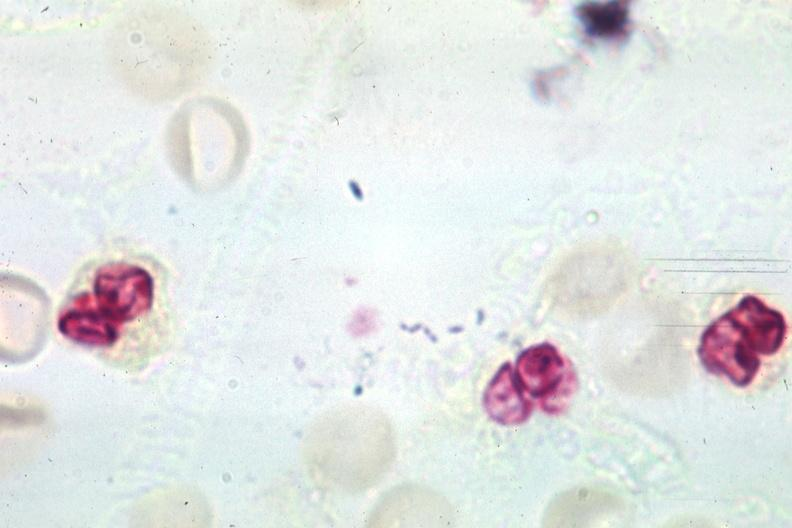what does this image show?
Answer the question using a single word or phrase. Gram organisms well shown 